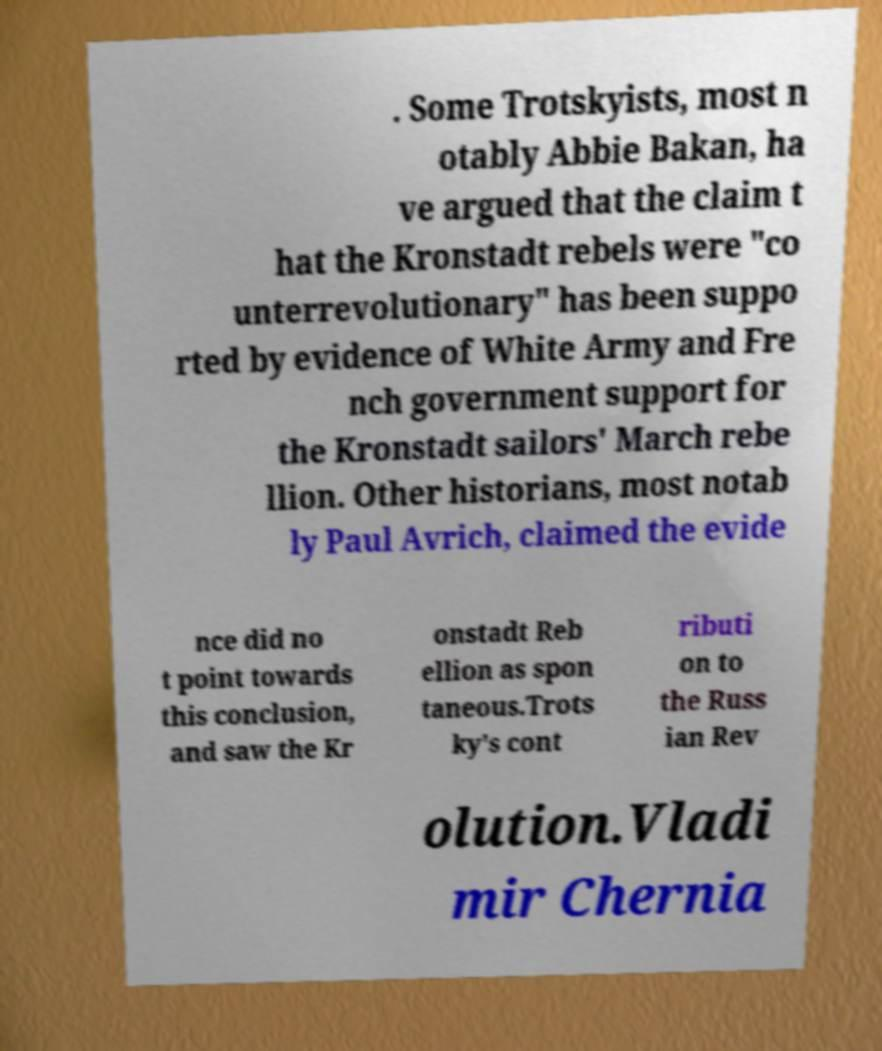Could you extract and type out the text from this image? . Some Trotskyists, most n otably Abbie Bakan, ha ve argued that the claim t hat the Kronstadt rebels were "co unterrevolutionary" has been suppo rted by evidence of White Army and Fre nch government support for the Kronstadt sailors' March rebe llion. Other historians, most notab ly Paul Avrich, claimed the evide nce did no t point towards this conclusion, and saw the Kr onstadt Reb ellion as spon taneous.Trots ky's cont ributi on to the Russ ian Rev olution.Vladi mir Chernia 